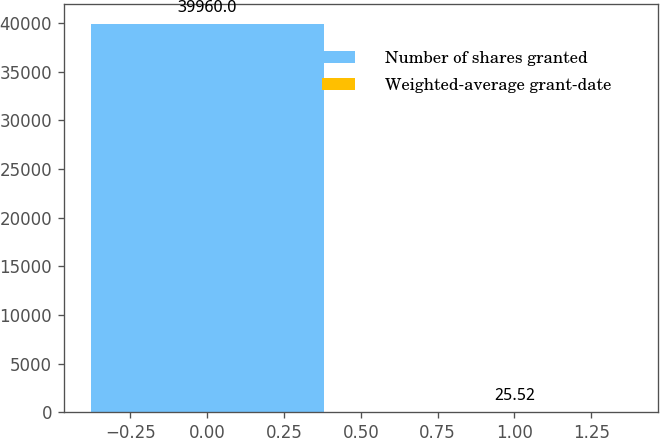Convert chart to OTSL. <chart><loc_0><loc_0><loc_500><loc_500><bar_chart><fcel>Number of shares granted<fcel>Weighted-average grant-date<nl><fcel>39960<fcel>25.52<nl></chart> 